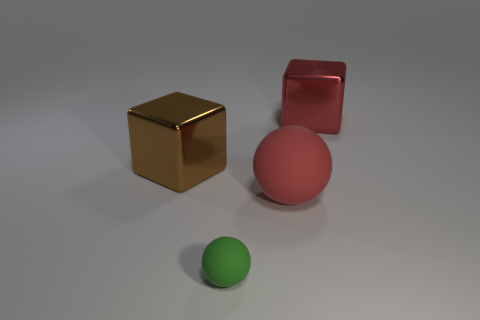Are there more brown blocks than big blue rubber balls? Actually, I cannot confirm if there are any big blue rubber balls present, as they are not visible in the image. The image only shows one gold block, one red block, and two spheres—one red and one green. 